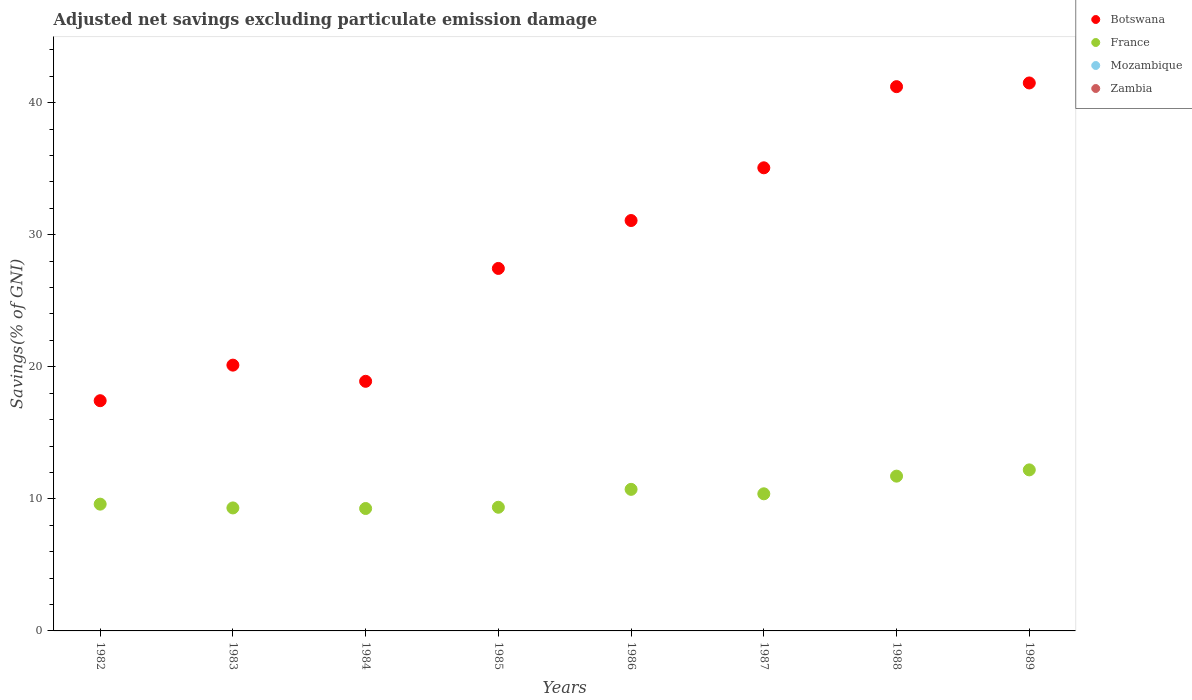Is the number of dotlines equal to the number of legend labels?
Provide a succinct answer. No. What is the adjusted net savings in France in 1982?
Offer a very short reply. 9.6. Across all years, what is the maximum adjusted net savings in Botswana?
Your response must be concise. 41.49. Across all years, what is the minimum adjusted net savings in Zambia?
Your answer should be compact. 0. In which year was the adjusted net savings in France maximum?
Make the answer very short. 1989. What is the total adjusted net savings in France in the graph?
Your answer should be very brief. 82.56. What is the difference between the adjusted net savings in France in 1983 and that in 1985?
Provide a short and direct response. -0.05. What is the difference between the adjusted net savings in Mozambique in 1985 and the adjusted net savings in France in 1986?
Make the answer very short. -10.72. In the year 1985, what is the difference between the adjusted net savings in Botswana and adjusted net savings in France?
Make the answer very short. 18.08. What is the ratio of the adjusted net savings in Botswana in 1984 to that in 1985?
Keep it short and to the point. 0.69. Is the difference between the adjusted net savings in Botswana in 1982 and 1985 greater than the difference between the adjusted net savings in France in 1982 and 1985?
Your answer should be very brief. No. What is the difference between the highest and the second highest adjusted net savings in France?
Keep it short and to the point. 0.47. What is the difference between the highest and the lowest adjusted net savings in Botswana?
Ensure brevity in your answer.  24.06. Is the sum of the adjusted net savings in France in 1986 and 1987 greater than the maximum adjusted net savings in Mozambique across all years?
Offer a very short reply. Yes. Is it the case that in every year, the sum of the adjusted net savings in Zambia and adjusted net savings in Botswana  is greater than the sum of adjusted net savings in Mozambique and adjusted net savings in France?
Provide a short and direct response. No. Is it the case that in every year, the sum of the adjusted net savings in Botswana and adjusted net savings in Zambia  is greater than the adjusted net savings in Mozambique?
Keep it short and to the point. Yes. How many dotlines are there?
Make the answer very short. 2. How many years are there in the graph?
Keep it short and to the point. 8. Does the graph contain any zero values?
Provide a succinct answer. Yes. Where does the legend appear in the graph?
Ensure brevity in your answer.  Top right. How many legend labels are there?
Make the answer very short. 4. What is the title of the graph?
Provide a short and direct response. Adjusted net savings excluding particulate emission damage. Does "Ecuador" appear as one of the legend labels in the graph?
Provide a succinct answer. No. What is the label or title of the Y-axis?
Ensure brevity in your answer.  Savings(% of GNI). What is the Savings(% of GNI) of Botswana in 1982?
Offer a very short reply. 17.43. What is the Savings(% of GNI) of France in 1982?
Your answer should be very brief. 9.6. What is the Savings(% of GNI) of Botswana in 1983?
Keep it short and to the point. 20.13. What is the Savings(% of GNI) of France in 1983?
Keep it short and to the point. 9.31. What is the Savings(% of GNI) in Mozambique in 1983?
Your answer should be compact. 0. What is the Savings(% of GNI) in Botswana in 1984?
Offer a very short reply. 18.9. What is the Savings(% of GNI) of France in 1984?
Ensure brevity in your answer.  9.27. What is the Savings(% of GNI) of Mozambique in 1984?
Provide a succinct answer. 0. What is the Savings(% of GNI) of Botswana in 1985?
Provide a succinct answer. 27.45. What is the Savings(% of GNI) in France in 1985?
Ensure brevity in your answer.  9.36. What is the Savings(% of GNI) of Zambia in 1985?
Offer a very short reply. 0. What is the Savings(% of GNI) in Botswana in 1986?
Make the answer very short. 31.07. What is the Savings(% of GNI) of France in 1986?
Your answer should be compact. 10.72. What is the Savings(% of GNI) in Zambia in 1986?
Ensure brevity in your answer.  0. What is the Savings(% of GNI) in Botswana in 1987?
Offer a terse response. 35.07. What is the Savings(% of GNI) in France in 1987?
Keep it short and to the point. 10.38. What is the Savings(% of GNI) in Zambia in 1987?
Ensure brevity in your answer.  0. What is the Savings(% of GNI) in Botswana in 1988?
Keep it short and to the point. 41.21. What is the Savings(% of GNI) in France in 1988?
Make the answer very short. 11.72. What is the Savings(% of GNI) of Mozambique in 1988?
Offer a terse response. 0. What is the Savings(% of GNI) of Botswana in 1989?
Ensure brevity in your answer.  41.49. What is the Savings(% of GNI) in France in 1989?
Provide a short and direct response. 12.19. What is the Savings(% of GNI) in Zambia in 1989?
Provide a short and direct response. 0. Across all years, what is the maximum Savings(% of GNI) of Botswana?
Offer a terse response. 41.49. Across all years, what is the maximum Savings(% of GNI) of France?
Offer a terse response. 12.19. Across all years, what is the minimum Savings(% of GNI) in Botswana?
Your answer should be very brief. 17.43. Across all years, what is the minimum Savings(% of GNI) in France?
Your response must be concise. 9.27. What is the total Savings(% of GNI) in Botswana in the graph?
Provide a short and direct response. 232.75. What is the total Savings(% of GNI) of France in the graph?
Keep it short and to the point. 82.56. What is the total Savings(% of GNI) of Mozambique in the graph?
Offer a very short reply. 0. What is the total Savings(% of GNI) in Zambia in the graph?
Your answer should be compact. 0. What is the difference between the Savings(% of GNI) in Botswana in 1982 and that in 1983?
Make the answer very short. -2.69. What is the difference between the Savings(% of GNI) of France in 1982 and that in 1983?
Give a very brief answer. 0.29. What is the difference between the Savings(% of GNI) in Botswana in 1982 and that in 1984?
Ensure brevity in your answer.  -1.47. What is the difference between the Savings(% of GNI) in France in 1982 and that in 1984?
Your response must be concise. 0.33. What is the difference between the Savings(% of GNI) of Botswana in 1982 and that in 1985?
Give a very brief answer. -10.02. What is the difference between the Savings(% of GNI) in France in 1982 and that in 1985?
Your answer should be compact. 0.24. What is the difference between the Savings(% of GNI) in Botswana in 1982 and that in 1986?
Your answer should be compact. -13.64. What is the difference between the Savings(% of GNI) in France in 1982 and that in 1986?
Give a very brief answer. -1.12. What is the difference between the Savings(% of GNI) of Botswana in 1982 and that in 1987?
Keep it short and to the point. -17.63. What is the difference between the Savings(% of GNI) of France in 1982 and that in 1987?
Provide a short and direct response. -0.78. What is the difference between the Savings(% of GNI) of Botswana in 1982 and that in 1988?
Your response must be concise. -23.78. What is the difference between the Savings(% of GNI) in France in 1982 and that in 1988?
Keep it short and to the point. -2.12. What is the difference between the Savings(% of GNI) of Botswana in 1982 and that in 1989?
Keep it short and to the point. -24.06. What is the difference between the Savings(% of GNI) in France in 1982 and that in 1989?
Ensure brevity in your answer.  -2.59. What is the difference between the Savings(% of GNI) of Botswana in 1983 and that in 1984?
Give a very brief answer. 1.23. What is the difference between the Savings(% of GNI) in France in 1983 and that in 1984?
Offer a terse response. 0.04. What is the difference between the Savings(% of GNI) of Botswana in 1983 and that in 1985?
Provide a short and direct response. -7.32. What is the difference between the Savings(% of GNI) in France in 1983 and that in 1985?
Make the answer very short. -0.05. What is the difference between the Savings(% of GNI) in Botswana in 1983 and that in 1986?
Offer a very short reply. -10.95. What is the difference between the Savings(% of GNI) of France in 1983 and that in 1986?
Your answer should be compact. -1.41. What is the difference between the Savings(% of GNI) in Botswana in 1983 and that in 1987?
Ensure brevity in your answer.  -14.94. What is the difference between the Savings(% of GNI) in France in 1983 and that in 1987?
Provide a short and direct response. -1.07. What is the difference between the Savings(% of GNI) in Botswana in 1983 and that in 1988?
Your answer should be compact. -21.09. What is the difference between the Savings(% of GNI) in France in 1983 and that in 1988?
Offer a terse response. -2.41. What is the difference between the Savings(% of GNI) of Botswana in 1983 and that in 1989?
Give a very brief answer. -21.37. What is the difference between the Savings(% of GNI) of France in 1983 and that in 1989?
Keep it short and to the point. -2.88. What is the difference between the Savings(% of GNI) of Botswana in 1984 and that in 1985?
Keep it short and to the point. -8.55. What is the difference between the Savings(% of GNI) in France in 1984 and that in 1985?
Your response must be concise. -0.09. What is the difference between the Savings(% of GNI) of Botswana in 1984 and that in 1986?
Your answer should be very brief. -12.17. What is the difference between the Savings(% of GNI) in France in 1984 and that in 1986?
Keep it short and to the point. -1.45. What is the difference between the Savings(% of GNI) in Botswana in 1984 and that in 1987?
Provide a succinct answer. -16.17. What is the difference between the Savings(% of GNI) of France in 1984 and that in 1987?
Give a very brief answer. -1.11. What is the difference between the Savings(% of GNI) of Botswana in 1984 and that in 1988?
Your answer should be very brief. -22.31. What is the difference between the Savings(% of GNI) of France in 1984 and that in 1988?
Provide a succinct answer. -2.45. What is the difference between the Savings(% of GNI) in Botswana in 1984 and that in 1989?
Your answer should be very brief. -22.59. What is the difference between the Savings(% of GNI) of France in 1984 and that in 1989?
Keep it short and to the point. -2.92. What is the difference between the Savings(% of GNI) in Botswana in 1985 and that in 1986?
Keep it short and to the point. -3.63. What is the difference between the Savings(% of GNI) in France in 1985 and that in 1986?
Give a very brief answer. -1.36. What is the difference between the Savings(% of GNI) of Botswana in 1985 and that in 1987?
Offer a very short reply. -7.62. What is the difference between the Savings(% of GNI) of France in 1985 and that in 1987?
Make the answer very short. -1.02. What is the difference between the Savings(% of GNI) in Botswana in 1985 and that in 1988?
Your answer should be very brief. -13.76. What is the difference between the Savings(% of GNI) of France in 1985 and that in 1988?
Ensure brevity in your answer.  -2.36. What is the difference between the Savings(% of GNI) in Botswana in 1985 and that in 1989?
Provide a short and direct response. -14.04. What is the difference between the Savings(% of GNI) in France in 1985 and that in 1989?
Give a very brief answer. -2.83. What is the difference between the Savings(% of GNI) of Botswana in 1986 and that in 1987?
Make the answer very short. -3.99. What is the difference between the Savings(% of GNI) of France in 1986 and that in 1987?
Offer a very short reply. 0.34. What is the difference between the Savings(% of GNI) of Botswana in 1986 and that in 1988?
Your answer should be compact. -10.14. What is the difference between the Savings(% of GNI) in France in 1986 and that in 1988?
Provide a short and direct response. -1. What is the difference between the Savings(% of GNI) of Botswana in 1986 and that in 1989?
Keep it short and to the point. -10.42. What is the difference between the Savings(% of GNI) in France in 1986 and that in 1989?
Make the answer very short. -1.47. What is the difference between the Savings(% of GNI) of Botswana in 1987 and that in 1988?
Ensure brevity in your answer.  -6.14. What is the difference between the Savings(% of GNI) in France in 1987 and that in 1988?
Provide a short and direct response. -1.34. What is the difference between the Savings(% of GNI) in Botswana in 1987 and that in 1989?
Make the answer very short. -6.42. What is the difference between the Savings(% of GNI) in France in 1987 and that in 1989?
Provide a short and direct response. -1.81. What is the difference between the Savings(% of GNI) of Botswana in 1988 and that in 1989?
Your response must be concise. -0.28. What is the difference between the Savings(% of GNI) in France in 1988 and that in 1989?
Keep it short and to the point. -0.47. What is the difference between the Savings(% of GNI) of Botswana in 1982 and the Savings(% of GNI) of France in 1983?
Your answer should be compact. 8.12. What is the difference between the Savings(% of GNI) of Botswana in 1982 and the Savings(% of GNI) of France in 1984?
Make the answer very short. 8.16. What is the difference between the Savings(% of GNI) of Botswana in 1982 and the Savings(% of GNI) of France in 1985?
Ensure brevity in your answer.  8.07. What is the difference between the Savings(% of GNI) of Botswana in 1982 and the Savings(% of GNI) of France in 1986?
Provide a short and direct response. 6.71. What is the difference between the Savings(% of GNI) in Botswana in 1982 and the Savings(% of GNI) in France in 1987?
Make the answer very short. 7.05. What is the difference between the Savings(% of GNI) of Botswana in 1982 and the Savings(% of GNI) of France in 1988?
Offer a very short reply. 5.71. What is the difference between the Savings(% of GNI) in Botswana in 1982 and the Savings(% of GNI) in France in 1989?
Offer a terse response. 5.24. What is the difference between the Savings(% of GNI) in Botswana in 1983 and the Savings(% of GNI) in France in 1984?
Keep it short and to the point. 10.86. What is the difference between the Savings(% of GNI) of Botswana in 1983 and the Savings(% of GNI) of France in 1985?
Your answer should be compact. 10.76. What is the difference between the Savings(% of GNI) in Botswana in 1983 and the Savings(% of GNI) in France in 1986?
Make the answer very short. 9.41. What is the difference between the Savings(% of GNI) in Botswana in 1983 and the Savings(% of GNI) in France in 1987?
Your answer should be very brief. 9.74. What is the difference between the Savings(% of GNI) of Botswana in 1983 and the Savings(% of GNI) of France in 1988?
Offer a terse response. 8.4. What is the difference between the Savings(% of GNI) in Botswana in 1983 and the Savings(% of GNI) in France in 1989?
Your response must be concise. 7.93. What is the difference between the Savings(% of GNI) in Botswana in 1984 and the Savings(% of GNI) in France in 1985?
Provide a short and direct response. 9.54. What is the difference between the Savings(% of GNI) of Botswana in 1984 and the Savings(% of GNI) of France in 1986?
Provide a short and direct response. 8.18. What is the difference between the Savings(% of GNI) of Botswana in 1984 and the Savings(% of GNI) of France in 1987?
Provide a succinct answer. 8.52. What is the difference between the Savings(% of GNI) of Botswana in 1984 and the Savings(% of GNI) of France in 1988?
Provide a short and direct response. 7.18. What is the difference between the Savings(% of GNI) of Botswana in 1984 and the Savings(% of GNI) of France in 1989?
Keep it short and to the point. 6.71. What is the difference between the Savings(% of GNI) in Botswana in 1985 and the Savings(% of GNI) in France in 1986?
Your response must be concise. 16.73. What is the difference between the Savings(% of GNI) in Botswana in 1985 and the Savings(% of GNI) in France in 1987?
Give a very brief answer. 17.06. What is the difference between the Savings(% of GNI) in Botswana in 1985 and the Savings(% of GNI) in France in 1988?
Your answer should be very brief. 15.73. What is the difference between the Savings(% of GNI) in Botswana in 1985 and the Savings(% of GNI) in France in 1989?
Keep it short and to the point. 15.25. What is the difference between the Savings(% of GNI) in Botswana in 1986 and the Savings(% of GNI) in France in 1987?
Your answer should be compact. 20.69. What is the difference between the Savings(% of GNI) in Botswana in 1986 and the Savings(% of GNI) in France in 1988?
Your response must be concise. 19.35. What is the difference between the Savings(% of GNI) of Botswana in 1986 and the Savings(% of GNI) of France in 1989?
Offer a terse response. 18.88. What is the difference between the Savings(% of GNI) in Botswana in 1987 and the Savings(% of GNI) in France in 1988?
Your response must be concise. 23.35. What is the difference between the Savings(% of GNI) of Botswana in 1987 and the Savings(% of GNI) of France in 1989?
Ensure brevity in your answer.  22.87. What is the difference between the Savings(% of GNI) of Botswana in 1988 and the Savings(% of GNI) of France in 1989?
Your response must be concise. 29.02. What is the average Savings(% of GNI) in Botswana per year?
Give a very brief answer. 29.09. What is the average Savings(% of GNI) in France per year?
Offer a terse response. 10.32. What is the average Savings(% of GNI) of Mozambique per year?
Make the answer very short. 0. What is the average Savings(% of GNI) in Zambia per year?
Provide a succinct answer. 0. In the year 1982, what is the difference between the Savings(% of GNI) of Botswana and Savings(% of GNI) of France?
Offer a terse response. 7.83. In the year 1983, what is the difference between the Savings(% of GNI) in Botswana and Savings(% of GNI) in France?
Provide a short and direct response. 10.81. In the year 1984, what is the difference between the Savings(% of GNI) in Botswana and Savings(% of GNI) in France?
Provide a succinct answer. 9.63. In the year 1985, what is the difference between the Savings(% of GNI) in Botswana and Savings(% of GNI) in France?
Ensure brevity in your answer.  18.08. In the year 1986, what is the difference between the Savings(% of GNI) of Botswana and Savings(% of GNI) of France?
Provide a succinct answer. 20.36. In the year 1987, what is the difference between the Savings(% of GNI) of Botswana and Savings(% of GNI) of France?
Your answer should be compact. 24.68. In the year 1988, what is the difference between the Savings(% of GNI) of Botswana and Savings(% of GNI) of France?
Your response must be concise. 29.49. In the year 1989, what is the difference between the Savings(% of GNI) of Botswana and Savings(% of GNI) of France?
Give a very brief answer. 29.3. What is the ratio of the Savings(% of GNI) in Botswana in 1982 to that in 1983?
Offer a terse response. 0.87. What is the ratio of the Savings(% of GNI) in France in 1982 to that in 1983?
Provide a short and direct response. 1.03. What is the ratio of the Savings(% of GNI) in Botswana in 1982 to that in 1984?
Your response must be concise. 0.92. What is the ratio of the Savings(% of GNI) in France in 1982 to that in 1984?
Give a very brief answer. 1.04. What is the ratio of the Savings(% of GNI) of Botswana in 1982 to that in 1985?
Make the answer very short. 0.64. What is the ratio of the Savings(% of GNI) of France in 1982 to that in 1985?
Offer a terse response. 1.03. What is the ratio of the Savings(% of GNI) in Botswana in 1982 to that in 1986?
Ensure brevity in your answer.  0.56. What is the ratio of the Savings(% of GNI) in France in 1982 to that in 1986?
Your answer should be very brief. 0.9. What is the ratio of the Savings(% of GNI) of Botswana in 1982 to that in 1987?
Your answer should be compact. 0.5. What is the ratio of the Savings(% of GNI) of France in 1982 to that in 1987?
Your answer should be very brief. 0.92. What is the ratio of the Savings(% of GNI) in Botswana in 1982 to that in 1988?
Ensure brevity in your answer.  0.42. What is the ratio of the Savings(% of GNI) of France in 1982 to that in 1988?
Provide a short and direct response. 0.82. What is the ratio of the Savings(% of GNI) in Botswana in 1982 to that in 1989?
Your answer should be compact. 0.42. What is the ratio of the Savings(% of GNI) of France in 1982 to that in 1989?
Give a very brief answer. 0.79. What is the ratio of the Savings(% of GNI) of Botswana in 1983 to that in 1984?
Give a very brief answer. 1.06. What is the ratio of the Savings(% of GNI) in France in 1983 to that in 1984?
Ensure brevity in your answer.  1. What is the ratio of the Savings(% of GNI) of Botswana in 1983 to that in 1985?
Offer a very short reply. 0.73. What is the ratio of the Savings(% of GNI) in Botswana in 1983 to that in 1986?
Your answer should be compact. 0.65. What is the ratio of the Savings(% of GNI) in France in 1983 to that in 1986?
Give a very brief answer. 0.87. What is the ratio of the Savings(% of GNI) of Botswana in 1983 to that in 1987?
Offer a very short reply. 0.57. What is the ratio of the Savings(% of GNI) of France in 1983 to that in 1987?
Your response must be concise. 0.9. What is the ratio of the Savings(% of GNI) in Botswana in 1983 to that in 1988?
Give a very brief answer. 0.49. What is the ratio of the Savings(% of GNI) of France in 1983 to that in 1988?
Offer a terse response. 0.79. What is the ratio of the Savings(% of GNI) in Botswana in 1983 to that in 1989?
Offer a terse response. 0.49. What is the ratio of the Savings(% of GNI) of France in 1983 to that in 1989?
Your response must be concise. 0.76. What is the ratio of the Savings(% of GNI) in Botswana in 1984 to that in 1985?
Keep it short and to the point. 0.69. What is the ratio of the Savings(% of GNI) of France in 1984 to that in 1985?
Make the answer very short. 0.99. What is the ratio of the Savings(% of GNI) of Botswana in 1984 to that in 1986?
Keep it short and to the point. 0.61. What is the ratio of the Savings(% of GNI) of France in 1984 to that in 1986?
Offer a terse response. 0.86. What is the ratio of the Savings(% of GNI) of Botswana in 1984 to that in 1987?
Your answer should be compact. 0.54. What is the ratio of the Savings(% of GNI) in France in 1984 to that in 1987?
Provide a short and direct response. 0.89. What is the ratio of the Savings(% of GNI) in Botswana in 1984 to that in 1988?
Make the answer very short. 0.46. What is the ratio of the Savings(% of GNI) in France in 1984 to that in 1988?
Ensure brevity in your answer.  0.79. What is the ratio of the Savings(% of GNI) of Botswana in 1984 to that in 1989?
Keep it short and to the point. 0.46. What is the ratio of the Savings(% of GNI) of France in 1984 to that in 1989?
Keep it short and to the point. 0.76. What is the ratio of the Savings(% of GNI) of Botswana in 1985 to that in 1986?
Provide a short and direct response. 0.88. What is the ratio of the Savings(% of GNI) of France in 1985 to that in 1986?
Offer a terse response. 0.87. What is the ratio of the Savings(% of GNI) of Botswana in 1985 to that in 1987?
Give a very brief answer. 0.78. What is the ratio of the Savings(% of GNI) of France in 1985 to that in 1987?
Offer a very short reply. 0.9. What is the ratio of the Savings(% of GNI) in Botswana in 1985 to that in 1988?
Offer a terse response. 0.67. What is the ratio of the Savings(% of GNI) of France in 1985 to that in 1988?
Give a very brief answer. 0.8. What is the ratio of the Savings(% of GNI) of Botswana in 1985 to that in 1989?
Your response must be concise. 0.66. What is the ratio of the Savings(% of GNI) in France in 1985 to that in 1989?
Your response must be concise. 0.77. What is the ratio of the Savings(% of GNI) of Botswana in 1986 to that in 1987?
Offer a very short reply. 0.89. What is the ratio of the Savings(% of GNI) in France in 1986 to that in 1987?
Make the answer very short. 1.03. What is the ratio of the Savings(% of GNI) of Botswana in 1986 to that in 1988?
Provide a succinct answer. 0.75. What is the ratio of the Savings(% of GNI) in France in 1986 to that in 1988?
Your answer should be very brief. 0.91. What is the ratio of the Savings(% of GNI) in Botswana in 1986 to that in 1989?
Keep it short and to the point. 0.75. What is the ratio of the Savings(% of GNI) of France in 1986 to that in 1989?
Your answer should be compact. 0.88. What is the ratio of the Savings(% of GNI) in Botswana in 1987 to that in 1988?
Keep it short and to the point. 0.85. What is the ratio of the Savings(% of GNI) in France in 1987 to that in 1988?
Your answer should be compact. 0.89. What is the ratio of the Savings(% of GNI) in Botswana in 1987 to that in 1989?
Your response must be concise. 0.85. What is the ratio of the Savings(% of GNI) of France in 1987 to that in 1989?
Offer a terse response. 0.85. What is the ratio of the Savings(% of GNI) in France in 1988 to that in 1989?
Provide a succinct answer. 0.96. What is the difference between the highest and the second highest Savings(% of GNI) of Botswana?
Ensure brevity in your answer.  0.28. What is the difference between the highest and the second highest Savings(% of GNI) in France?
Offer a terse response. 0.47. What is the difference between the highest and the lowest Savings(% of GNI) in Botswana?
Provide a succinct answer. 24.06. What is the difference between the highest and the lowest Savings(% of GNI) in France?
Keep it short and to the point. 2.92. 